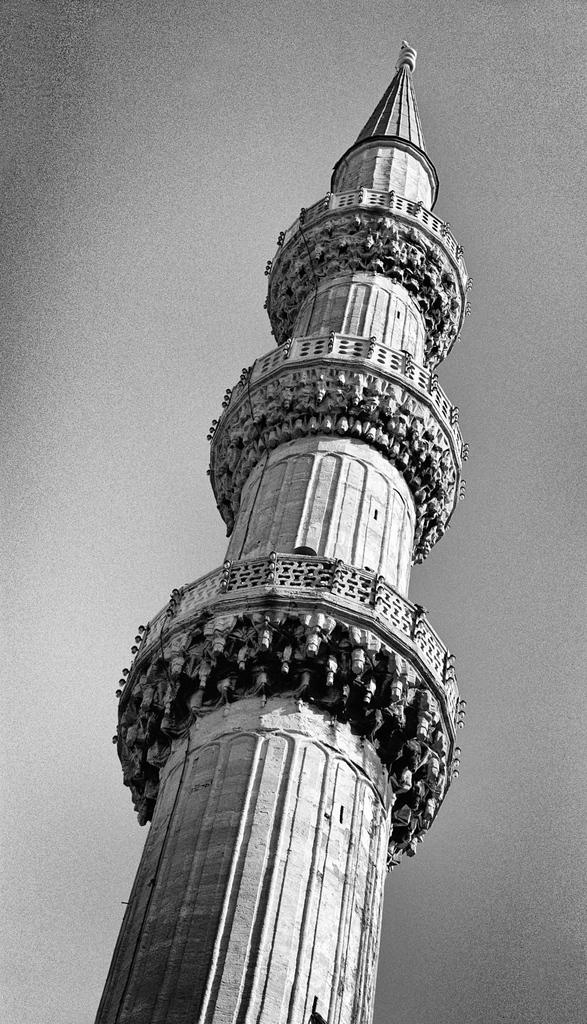What is the main subject in the center of the image? There is a tower in the center of the image. How many dimes are placed on the spade in the image? There are no dimes or spades present in the image; it features a tower. Is there a person visible in the image? There is no person visible in the image; it features a tower. 